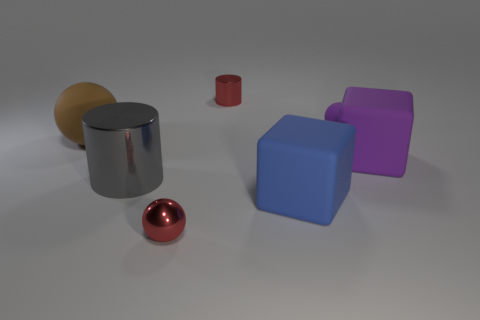There is a red object that is the same size as the metallic ball; what is its material?
Provide a short and direct response. Metal. What number of things are small purple rubber balls or cylinders left of the small metallic cylinder?
Your answer should be compact. 2. Do the matte object to the left of the red cylinder and the large gray thing have the same shape?
Keep it short and to the point. No. What number of small matte balls are in front of the metal thing to the left of the small red shiny object in front of the purple rubber cube?
Your answer should be compact. 0. How many objects are either large metallic objects or big brown objects?
Your response must be concise. 2. There is a blue rubber thing; is it the same shape as the purple matte thing that is in front of the brown sphere?
Your answer should be compact. Yes. There is a red shiny thing that is in front of the small cylinder; what is its shape?
Offer a very short reply. Sphere. Is the shape of the brown matte thing the same as the small purple thing?
Give a very brief answer. Yes. What is the size of the other object that is the same shape as the large gray shiny thing?
Give a very brief answer. Small. There is a thing that is in front of the blue rubber block; does it have the same size as the big gray cylinder?
Your response must be concise. No. 